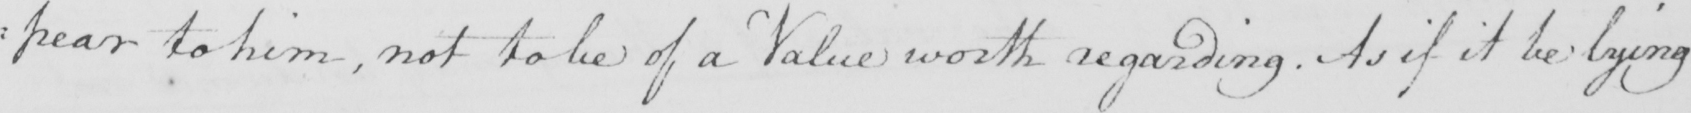What does this handwritten line say? : pear to him , not to be of a Value worth regarding . As if it be lying 